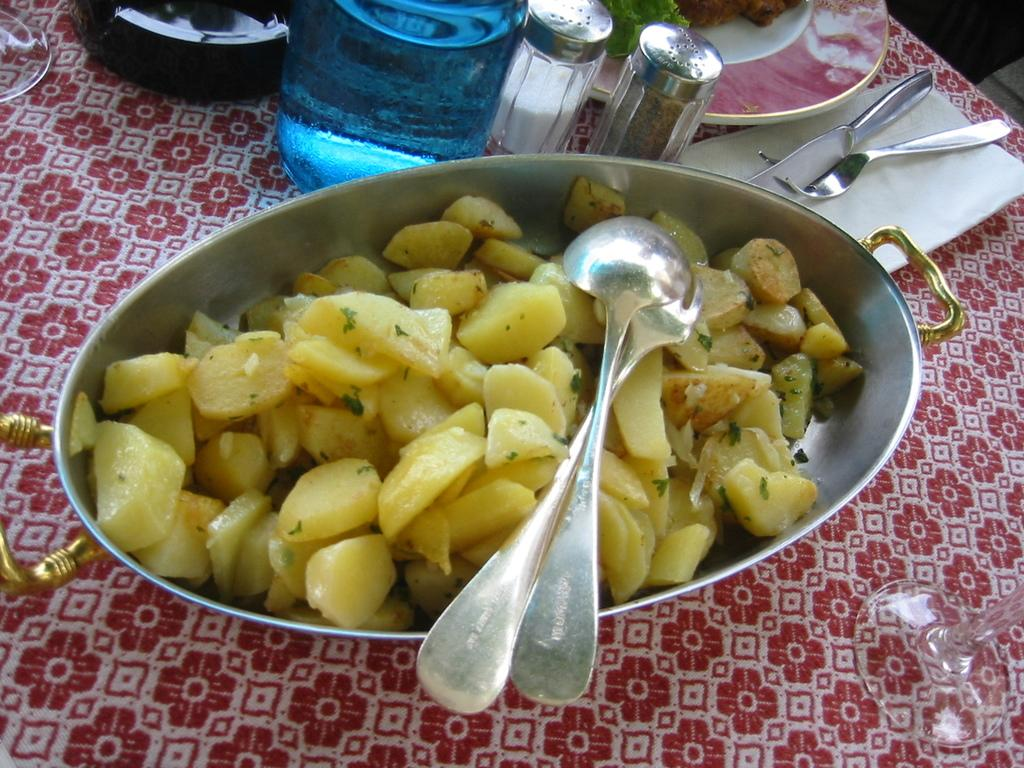What piece of furniture is present in the image? There is a table in the image. What is placed on the table? There is a bottle, plates, forks, tissues, and a bowl with a dish on the table. What type of utensils are on the table? There are forks on the table. What can be used for cleaning or wiping in the image? Tissues are present on the table for cleaning or wiping. What type of humor can be seen in the image? There is no humor present in the image; it is a still image of a table with various items on it. 